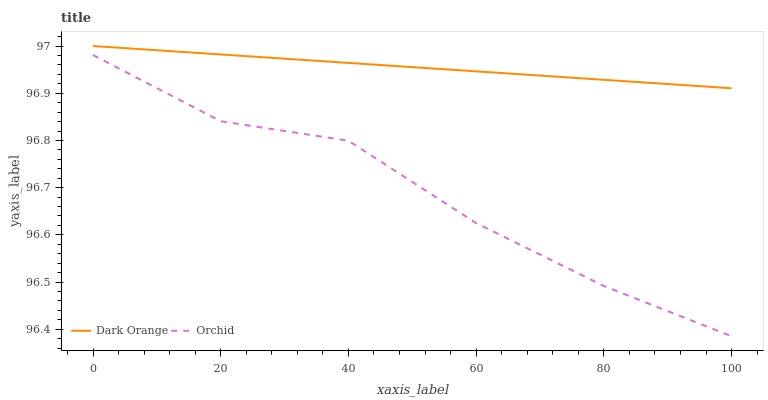Does Orchid have the minimum area under the curve?
Answer yes or no. Yes. Does Dark Orange have the maximum area under the curve?
Answer yes or no. Yes. Does Orchid have the maximum area under the curve?
Answer yes or no. No. Is Dark Orange the smoothest?
Answer yes or no. Yes. Is Orchid the roughest?
Answer yes or no. Yes. Is Orchid the smoothest?
Answer yes or no. No. Does Orchid have the lowest value?
Answer yes or no. Yes. Does Dark Orange have the highest value?
Answer yes or no. Yes. Does Orchid have the highest value?
Answer yes or no. No. Is Orchid less than Dark Orange?
Answer yes or no. Yes. Is Dark Orange greater than Orchid?
Answer yes or no. Yes. Does Orchid intersect Dark Orange?
Answer yes or no. No. 